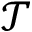Convert formula to latex. <formula><loc_0><loc_0><loc_500><loc_500>\mathcal { T }</formula> 